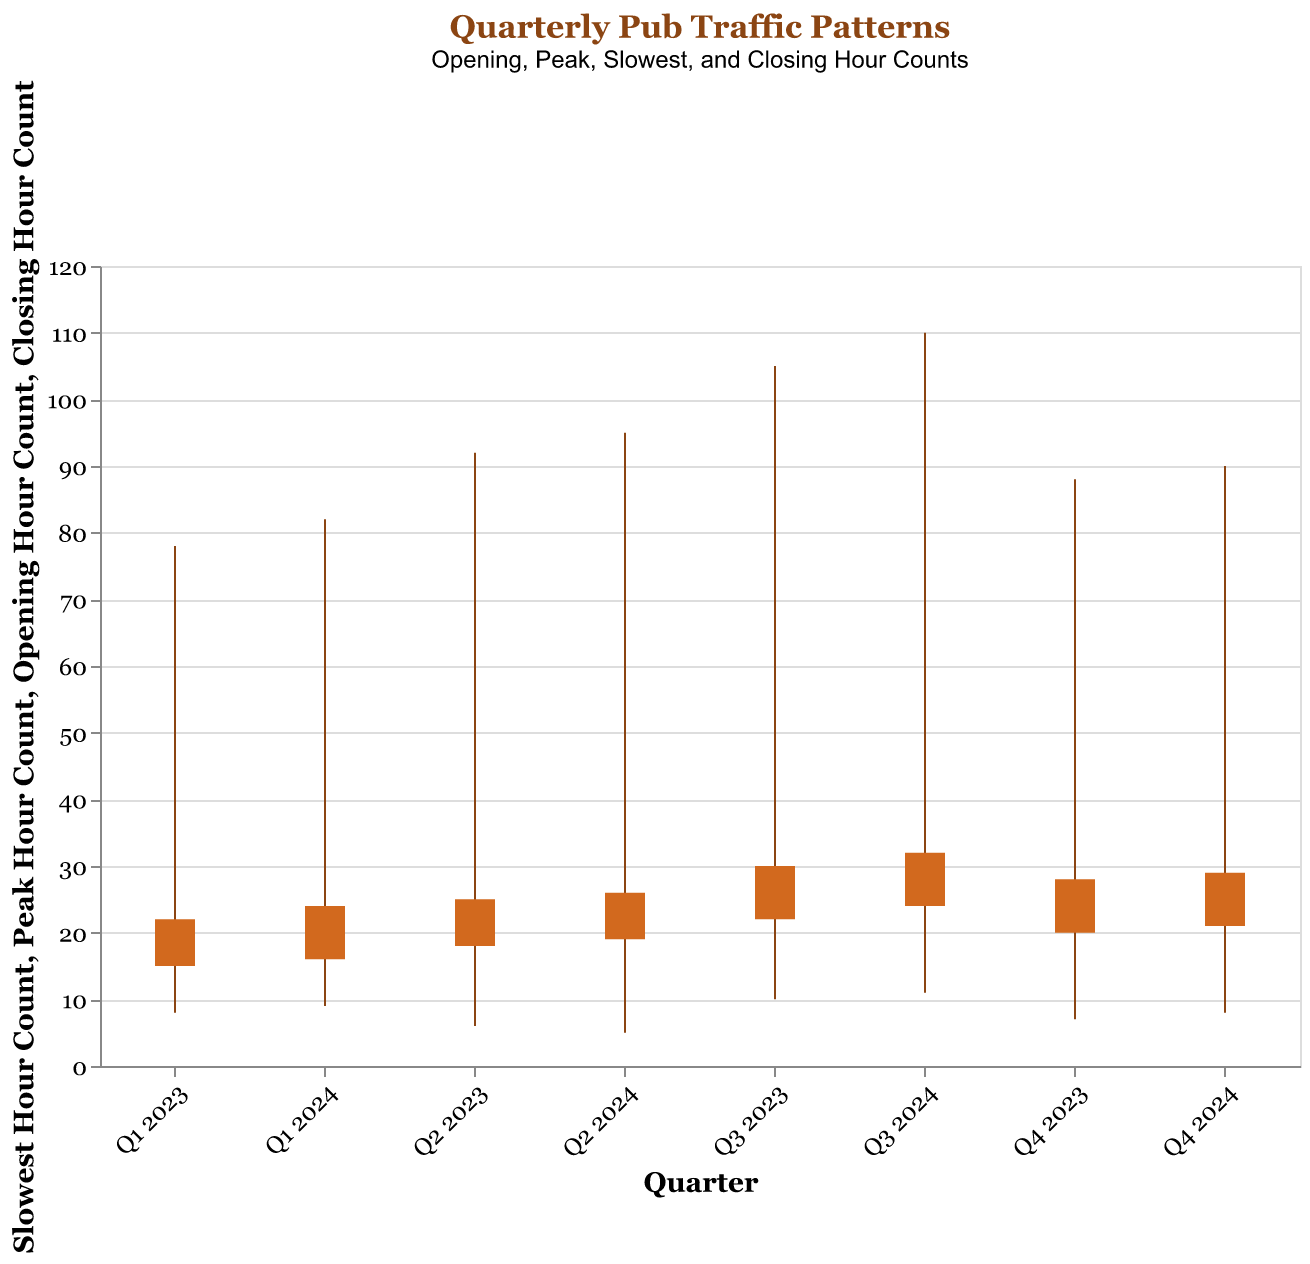Which quarter had the highest peak hour count? Look at the "Peak Hour Count" values for each quarter and identify the highest number. Q3 2024 has the highest peak hour count of 110.
Answer: Q3 2024 What is the title of the chart? The title is located at the top of the chart, which provides an overview of the visualized data. The title reads "Quarterly Pub Traffic Patterns."
Answer: Quarterly Pub Traffic Patterns Which quarter had the lowest slowest hour count? Compare the "Slowest Hour Count" values for each quarter. Q2 2024 has the lowest count of 5.
Answer: Q2 2024 What is the average opening hour count across all quarters? Sum all "Opening Hour Count" values and divide by the number of quarters. (15 + 18 + 22 + 20 + 16 + 19 + 24 + 21) / 8 = 155 / 8 = 19.375
Answer: 19.375 Between which two quarters does the peak hour count show the most significant increase? Calculate the difference in "Peak Hour Count" between successive quarters and identify the largest increase. The most significant increase is between Q2 2023 and Q3 2023 (105 - 92 = 13).
Answer: Q2 2023 and Q3 2023 Which quarter had close hour count exactly equal to 22? Check each quarter's "Closing Hour Count" value and see which one equals 22. Q1 2023 has a closing hour count of 22.
Answer: Q1 2023 How does the opening hour count in Q1 2024 compare to Q4 2023? Compare the "Opening Hour Count" values for Q1 2024 and Q4 2023. Q1 2024 has a count of 16, while Q4 2023 has a count of 20, so Q1 2024 is lower.
Answer: Q1 2024 is lower Are there any quarters where the closing hour count is higher than the peak hour count? Compare "Closing Hour Count" and "Peak Hour Count" values for each quarter. No quarter has a closing hour count higher than the peak hour count.
Answer: No What is the total closing hour count for the year 2023? Sum the "Closing Hour Count" values for all four quarters of 2023. 22 (Q1) + 25 (Q2) + 30 (Q3) + 28 (Q4) = 105
Answer: 105 